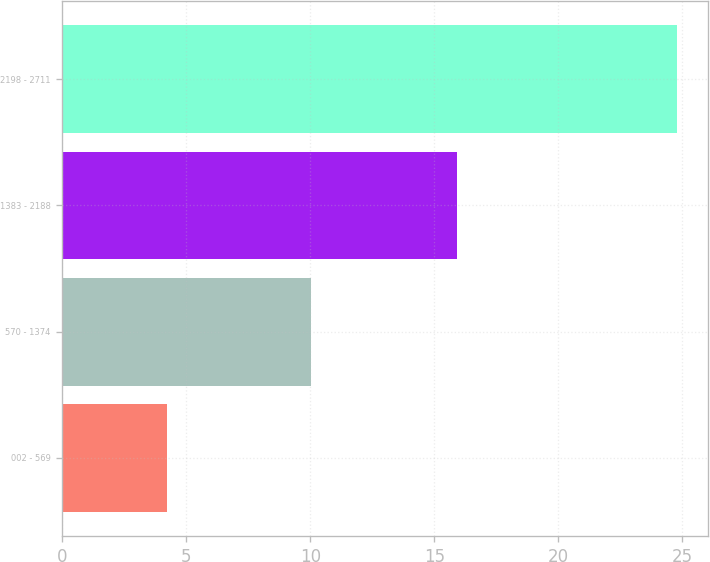Convert chart to OTSL. <chart><loc_0><loc_0><loc_500><loc_500><bar_chart><fcel>002 - 569<fcel>570 - 1374<fcel>1383 - 2188<fcel>2198 - 2711<nl><fcel>4.24<fcel>10.02<fcel>15.92<fcel>24.8<nl></chart> 